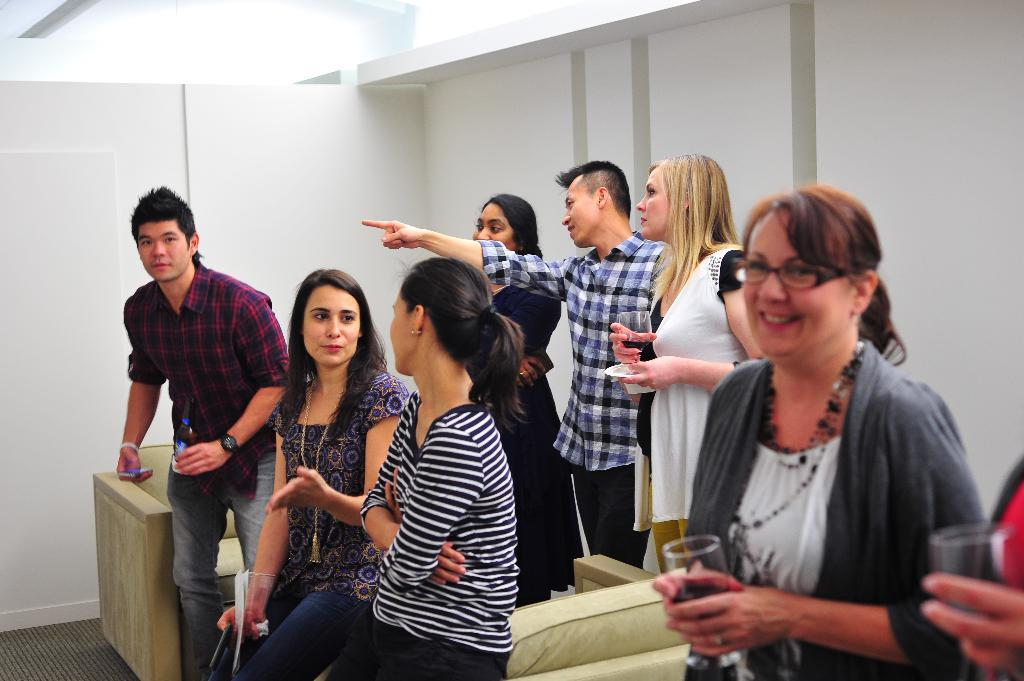What is happening in the image? There are people standing in the image. What type of furniture is present in the image? There is a sofa chair in the image. What can be seen in the background of the image? There is a wall in the background of the image. What is the woman on the right side holding? The woman on the right side is holding a glass. What does the stranger say to the manager in the image? There is no stranger or manager present in the image. 